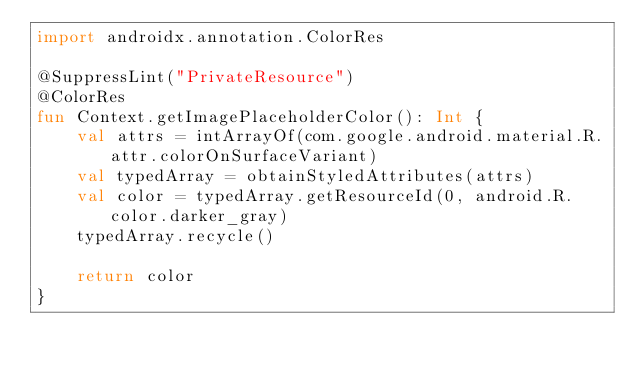<code> <loc_0><loc_0><loc_500><loc_500><_Kotlin_>import androidx.annotation.ColorRes

@SuppressLint("PrivateResource")
@ColorRes
fun Context.getImagePlaceholderColor(): Int {
    val attrs = intArrayOf(com.google.android.material.R.attr.colorOnSurfaceVariant)
    val typedArray = obtainStyledAttributes(attrs)
    val color = typedArray.getResourceId(0, android.R.color.darker_gray)
    typedArray.recycle()

    return color
}
</code> 